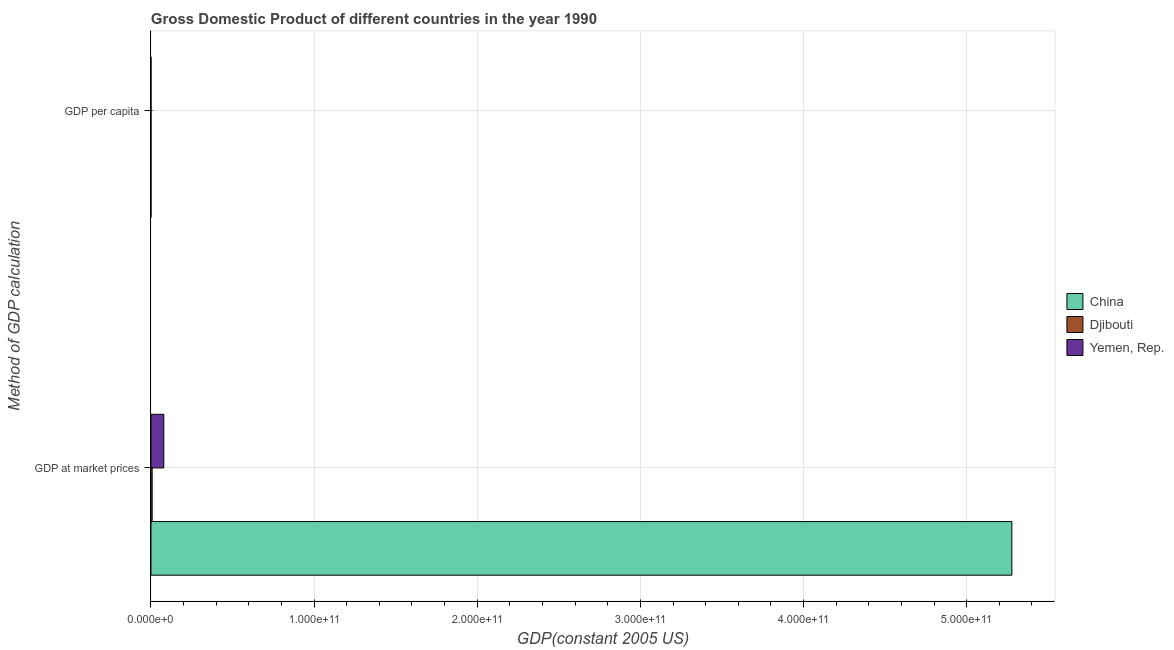How many different coloured bars are there?
Ensure brevity in your answer.  3. Are the number of bars on each tick of the Y-axis equal?
Offer a terse response. Yes. How many bars are there on the 1st tick from the top?
Ensure brevity in your answer.  3. How many bars are there on the 1st tick from the bottom?
Offer a terse response. 3. What is the label of the 1st group of bars from the top?
Keep it short and to the point. GDP per capita. What is the gdp per capita in Yemen, Rep.?
Keep it short and to the point. 656.95. Across all countries, what is the maximum gdp per capita?
Ensure brevity in your answer.  1245.79. Across all countries, what is the minimum gdp per capita?
Offer a very short reply. 464.87. In which country was the gdp at market prices minimum?
Provide a succinct answer. Djibouti. What is the total gdp per capita in the graph?
Ensure brevity in your answer.  2367.61. What is the difference between the gdp at market prices in Yemen, Rep. and that in China?
Your answer should be compact. -5.20e+11. What is the difference between the gdp at market prices in China and the gdp per capita in Djibouti?
Your response must be concise. 5.28e+11. What is the average gdp per capita per country?
Offer a very short reply. 789.2. What is the difference between the gdp per capita and gdp at market prices in Djibouti?
Give a very brief answer. -7.33e+08. In how many countries, is the gdp per capita greater than 500000000000 US$?
Offer a terse response. 0. What is the ratio of the gdp per capita in Djibouti to that in China?
Offer a terse response. 2.68. Is the gdp at market prices in China less than that in Yemen, Rep.?
Provide a short and direct response. No. What does the 1st bar from the top in GDP at market prices represents?
Give a very brief answer. Yemen, Rep. What does the 1st bar from the bottom in GDP per capita represents?
Offer a terse response. China. How many countries are there in the graph?
Provide a succinct answer. 3. What is the difference between two consecutive major ticks on the X-axis?
Make the answer very short. 1.00e+11. Does the graph contain any zero values?
Ensure brevity in your answer.  No. Where does the legend appear in the graph?
Offer a terse response. Center right. How many legend labels are there?
Offer a very short reply. 3. What is the title of the graph?
Give a very brief answer. Gross Domestic Product of different countries in the year 1990. Does "Samoa" appear as one of the legend labels in the graph?
Your answer should be very brief. No. What is the label or title of the X-axis?
Offer a terse response. GDP(constant 2005 US). What is the label or title of the Y-axis?
Give a very brief answer. Method of GDP calculation. What is the GDP(constant 2005 US) of China in GDP at market prices?
Provide a succinct answer. 5.28e+11. What is the GDP(constant 2005 US) of Djibouti in GDP at market prices?
Ensure brevity in your answer.  7.33e+08. What is the GDP(constant 2005 US) in Yemen, Rep. in GDP at market prices?
Offer a terse response. 7.86e+09. What is the GDP(constant 2005 US) in China in GDP per capita?
Provide a short and direct response. 464.87. What is the GDP(constant 2005 US) in Djibouti in GDP per capita?
Provide a succinct answer. 1245.79. What is the GDP(constant 2005 US) in Yemen, Rep. in GDP per capita?
Offer a very short reply. 656.95. Across all Method of GDP calculation, what is the maximum GDP(constant 2005 US) of China?
Offer a very short reply. 5.28e+11. Across all Method of GDP calculation, what is the maximum GDP(constant 2005 US) in Djibouti?
Provide a succinct answer. 7.33e+08. Across all Method of GDP calculation, what is the maximum GDP(constant 2005 US) in Yemen, Rep.?
Offer a terse response. 7.86e+09. Across all Method of GDP calculation, what is the minimum GDP(constant 2005 US) of China?
Make the answer very short. 464.87. Across all Method of GDP calculation, what is the minimum GDP(constant 2005 US) in Djibouti?
Give a very brief answer. 1245.79. Across all Method of GDP calculation, what is the minimum GDP(constant 2005 US) of Yemen, Rep.?
Your answer should be compact. 656.95. What is the total GDP(constant 2005 US) of China in the graph?
Offer a terse response. 5.28e+11. What is the total GDP(constant 2005 US) in Djibouti in the graph?
Your response must be concise. 7.33e+08. What is the total GDP(constant 2005 US) of Yemen, Rep. in the graph?
Ensure brevity in your answer.  7.86e+09. What is the difference between the GDP(constant 2005 US) of China in GDP at market prices and that in GDP per capita?
Keep it short and to the point. 5.28e+11. What is the difference between the GDP(constant 2005 US) in Djibouti in GDP at market prices and that in GDP per capita?
Your answer should be compact. 7.33e+08. What is the difference between the GDP(constant 2005 US) in Yemen, Rep. in GDP at market prices and that in GDP per capita?
Keep it short and to the point. 7.86e+09. What is the difference between the GDP(constant 2005 US) in China in GDP at market prices and the GDP(constant 2005 US) in Djibouti in GDP per capita?
Offer a very short reply. 5.28e+11. What is the difference between the GDP(constant 2005 US) in China in GDP at market prices and the GDP(constant 2005 US) in Yemen, Rep. in GDP per capita?
Offer a terse response. 5.28e+11. What is the difference between the GDP(constant 2005 US) in Djibouti in GDP at market prices and the GDP(constant 2005 US) in Yemen, Rep. in GDP per capita?
Keep it short and to the point. 7.33e+08. What is the average GDP(constant 2005 US) in China per Method of GDP calculation?
Keep it short and to the point. 2.64e+11. What is the average GDP(constant 2005 US) of Djibouti per Method of GDP calculation?
Provide a short and direct response. 3.66e+08. What is the average GDP(constant 2005 US) of Yemen, Rep. per Method of GDP calculation?
Provide a succinct answer. 3.93e+09. What is the difference between the GDP(constant 2005 US) in China and GDP(constant 2005 US) in Djibouti in GDP at market prices?
Your response must be concise. 5.27e+11. What is the difference between the GDP(constant 2005 US) in China and GDP(constant 2005 US) in Yemen, Rep. in GDP at market prices?
Provide a succinct answer. 5.20e+11. What is the difference between the GDP(constant 2005 US) of Djibouti and GDP(constant 2005 US) of Yemen, Rep. in GDP at market prices?
Provide a succinct answer. -7.12e+09. What is the difference between the GDP(constant 2005 US) of China and GDP(constant 2005 US) of Djibouti in GDP per capita?
Ensure brevity in your answer.  -780.91. What is the difference between the GDP(constant 2005 US) in China and GDP(constant 2005 US) in Yemen, Rep. in GDP per capita?
Your answer should be very brief. -192.08. What is the difference between the GDP(constant 2005 US) in Djibouti and GDP(constant 2005 US) in Yemen, Rep. in GDP per capita?
Your answer should be compact. 588.84. What is the ratio of the GDP(constant 2005 US) of China in GDP at market prices to that in GDP per capita?
Give a very brief answer. 1.14e+09. What is the ratio of the GDP(constant 2005 US) in Djibouti in GDP at market prices to that in GDP per capita?
Make the answer very short. 5.88e+05. What is the ratio of the GDP(constant 2005 US) of Yemen, Rep. in GDP at market prices to that in GDP per capita?
Your answer should be compact. 1.20e+07. What is the difference between the highest and the second highest GDP(constant 2005 US) of China?
Give a very brief answer. 5.28e+11. What is the difference between the highest and the second highest GDP(constant 2005 US) of Djibouti?
Your answer should be very brief. 7.33e+08. What is the difference between the highest and the second highest GDP(constant 2005 US) in Yemen, Rep.?
Give a very brief answer. 7.86e+09. What is the difference between the highest and the lowest GDP(constant 2005 US) in China?
Give a very brief answer. 5.28e+11. What is the difference between the highest and the lowest GDP(constant 2005 US) of Djibouti?
Provide a succinct answer. 7.33e+08. What is the difference between the highest and the lowest GDP(constant 2005 US) of Yemen, Rep.?
Make the answer very short. 7.86e+09. 